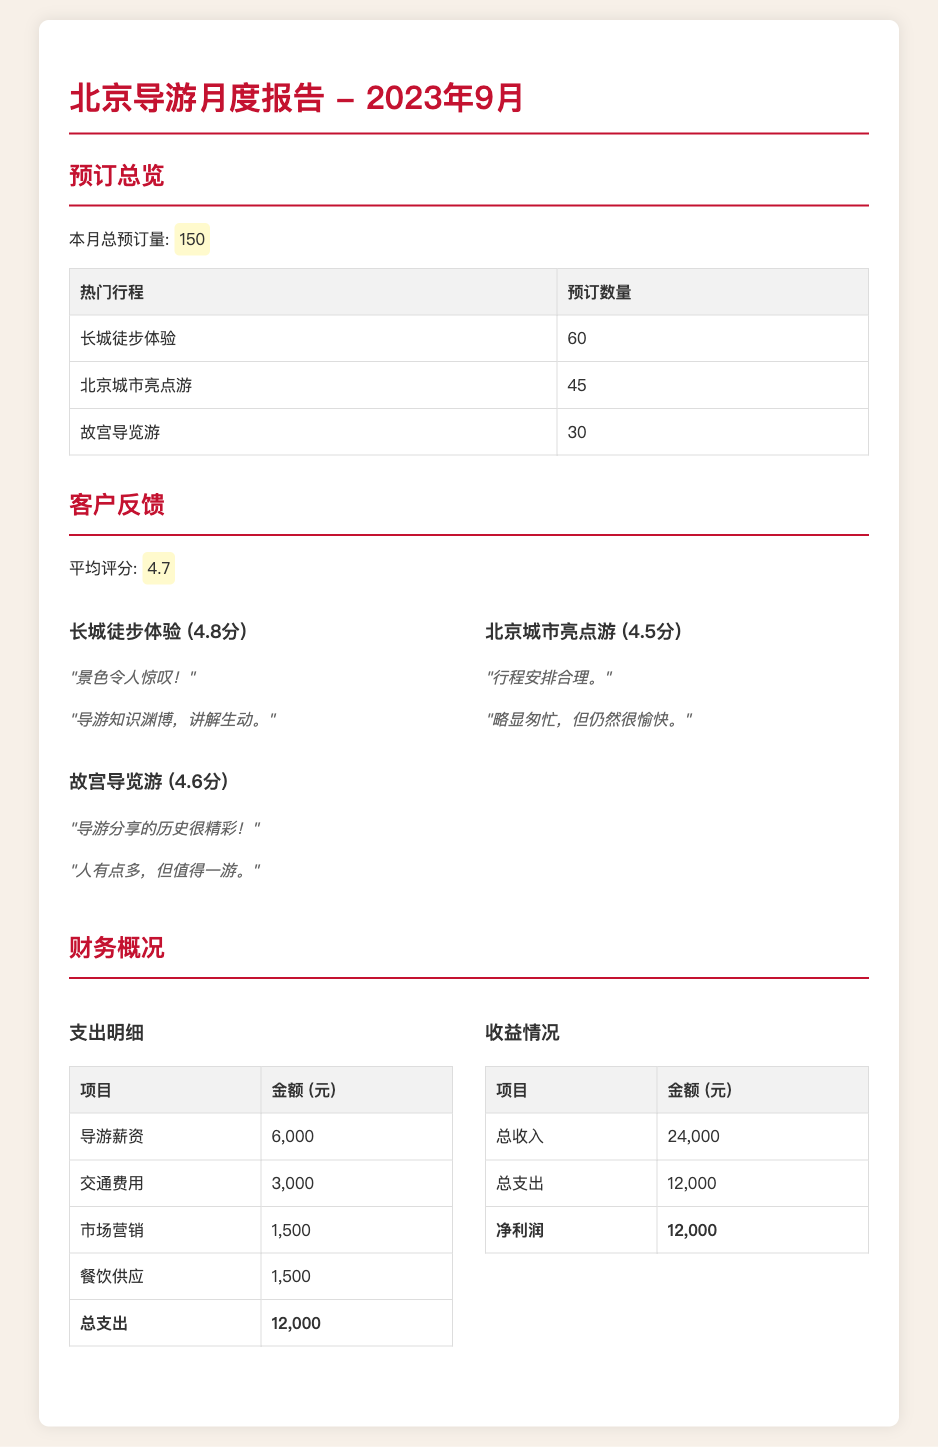what is the total number of bookings this month? The document states the total bookings for the month as 150.
Answer: 150 what is the average customer feedback score? The document lists the average score from customer feedback as 4.7.
Answer: 4.7 what is the total revenue generated? The document specifies the total revenue as 24,000 yuan.
Answer: 24,000 how much was spent on transportation? The document details transportation expenses as 3,000 yuan.
Answer: 3,000 which tour received the highest rating? According to the feedback section, the Great Wall Hiking Experience received a score of 4.8, the highest among the tours.
Answer: 长城徒步体验 what is the total expenditure reported? The total expenses for the month are highlighted in the document as 12,000 yuan.
Answer: 12,000 how many bookings were made for the Beijing city highlights tour? The document lists the bookings for the Beijing city highlights tour as 45.
Answer: 45 what is the net profit from the tours? The document calculates the net profit as total revenue minus total expenses, which is 12,000 yuan.
Answer: 12,000 how much was allocated for marketing expenses? The document outlines marketing expenses as 1,500 yuan.
Answer: 1,500 